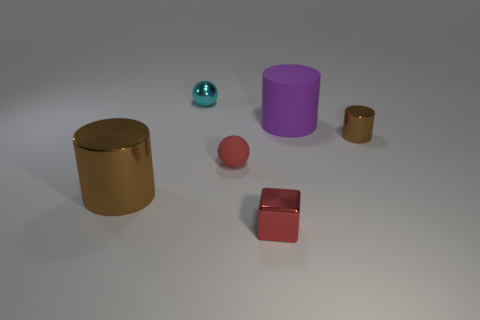What can you tell me about the lighting and shadows in the image? The scene is softly lit, with gentle shadows indicating a diffused light source above and slightly to the right. The shadows are soft-edged, with no harsh lines, giving the image a calm and uniform appearance. The lighting brings out the textures of the matte surfaces while highlighting the reflective qualities of the metallic objects. 